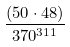<formula> <loc_0><loc_0><loc_500><loc_500>\frac { ( 5 0 \cdot 4 8 ) } { 3 7 0 ^ { 3 1 1 } }</formula> 